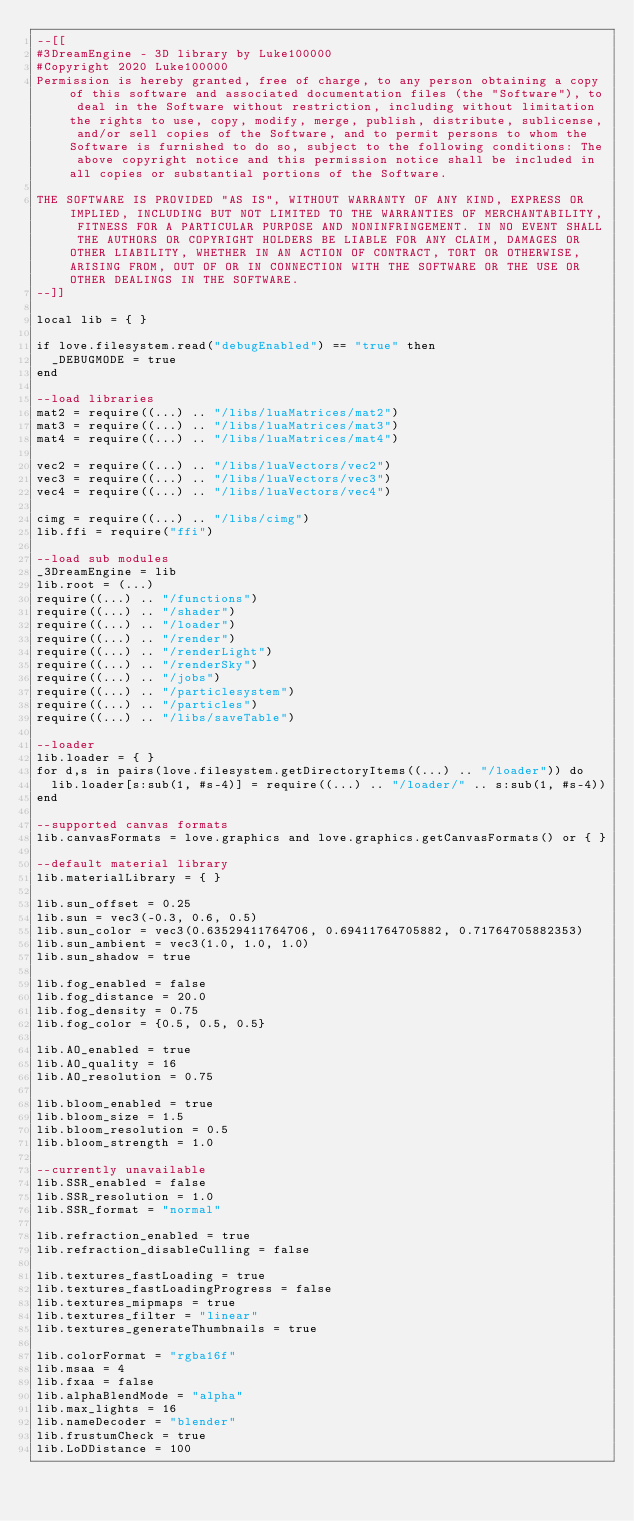Convert code to text. <code><loc_0><loc_0><loc_500><loc_500><_Lua_>--[[
#3DreamEngine - 3D library by Luke100000
#Copyright 2020 Luke100000
Permission is hereby granted, free of charge, to any person obtaining a copy of this software and associated documentation files (the "Software"), to deal in the Software without restriction, including without limitation the rights to use, copy, modify, merge, publish, distribute, sublicense, and/or sell copies of the Software, and to permit persons to whom the Software is furnished to do so, subject to the following conditions: The above copyright notice and this permission notice shall be included in all copies or substantial portions of the Software.

THE SOFTWARE IS PROVIDED "AS IS", WITHOUT WARRANTY OF ANY KIND, EXPRESS OR IMPLIED, INCLUDING BUT NOT LIMITED TO THE WARRANTIES OF MERCHANTABILITY, FITNESS FOR A PARTICULAR PURPOSE AND NONINFRINGEMENT. IN NO EVENT SHALL THE AUTHORS OR COPYRIGHT HOLDERS BE LIABLE FOR ANY CLAIM, DAMAGES OR OTHER LIABILITY, WHETHER IN AN ACTION OF CONTRACT, TORT OR OTHERWISE, ARISING FROM, OUT OF OR IN CONNECTION WITH THE SOFTWARE OR THE USE OR OTHER DEALINGS IN THE SOFTWARE.
--]]

local lib = { }

if love.filesystem.read("debugEnabled") == "true" then
	_DEBUGMODE = true
end

--load libraries
mat2 = require((...) .. "/libs/luaMatrices/mat2")
mat3 = require((...) .. "/libs/luaMatrices/mat3")
mat4 = require((...) .. "/libs/luaMatrices/mat4")

vec2 = require((...) .. "/libs/luaVectors/vec2")
vec3 = require((...) .. "/libs/luaVectors/vec3")
vec4 = require((...) .. "/libs/luaVectors/vec4")

cimg = require((...) .. "/libs/cimg")
lib.ffi = require("ffi")

--load sub modules
_3DreamEngine = lib
lib.root = (...)
require((...) .. "/functions")
require((...) .. "/shader")
require((...) .. "/loader")
require((...) .. "/render")
require((...) .. "/renderLight")
require((...) .. "/renderSky")
require((...) .. "/jobs")
require((...) .. "/particlesystem")
require((...) .. "/particles")
require((...) .. "/libs/saveTable")

--loader
lib.loader = { }
for d,s in pairs(love.filesystem.getDirectoryItems((...) .. "/loader")) do
	lib.loader[s:sub(1, #s-4)] = require((...) .. "/loader/" .. s:sub(1, #s-4))
end

--supported canvas formats
lib.canvasFormats = love.graphics and love.graphics.getCanvasFormats() or { }

--default material library
lib.materialLibrary = { }

lib.sun_offset = 0.25
lib.sun = vec3(-0.3, 0.6, 0.5)
lib.sun_color = vec3(0.63529411764706, 0.69411764705882, 0.71764705882353)
lib.sun_ambient = vec3(1.0, 1.0, 1.0)
lib.sun_shadow = true

lib.fog_enabled = false
lib.fog_distance = 20.0
lib.fog_density = 0.75
lib.fog_color = {0.5, 0.5, 0.5}

lib.AO_enabled = true
lib.AO_quality = 16
lib.AO_resolution = 0.75

lib.bloom_enabled = true
lib.bloom_size = 1.5
lib.bloom_resolution = 0.5
lib.bloom_strength = 1.0

--currently unavailable
lib.SSR_enabled = false
lib.SSR_resolution = 1.0
lib.SSR_format = "normal"

lib.refraction_enabled = true
lib.refraction_disableCulling = false

lib.textures_fastLoading = true
lib.textures_fastLoadingProgress = false
lib.textures_mipmaps = true
lib.textures_filter = "linear"
lib.textures_generateThumbnails = true

lib.colorFormat = "rgba16f"
lib.msaa = 4
lib.fxaa = false
lib.alphaBlendMode = "alpha"
lib.max_lights = 16
lib.nameDecoder = "blender"
lib.frustumCheck = true
lib.LoDDistance = 100
</code> 